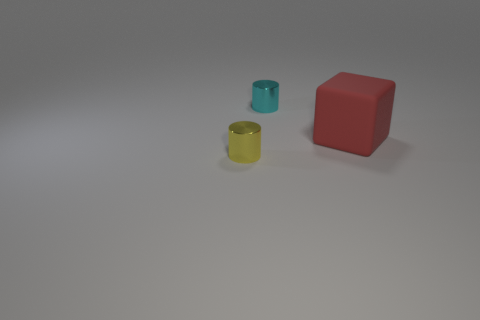Add 2 big brown matte balls. How many objects exist? 5 Subtract all cylinders. How many objects are left? 1 Add 2 red matte things. How many red matte things exist? 3 Subtract 0 yellow blocks. How many objects are left? 3 Subtract all yellow rubber cubes. Subtract all big red rubber objects. How many objects are left? 2 Add 2 yellow things. How many yellow things are left? 3 